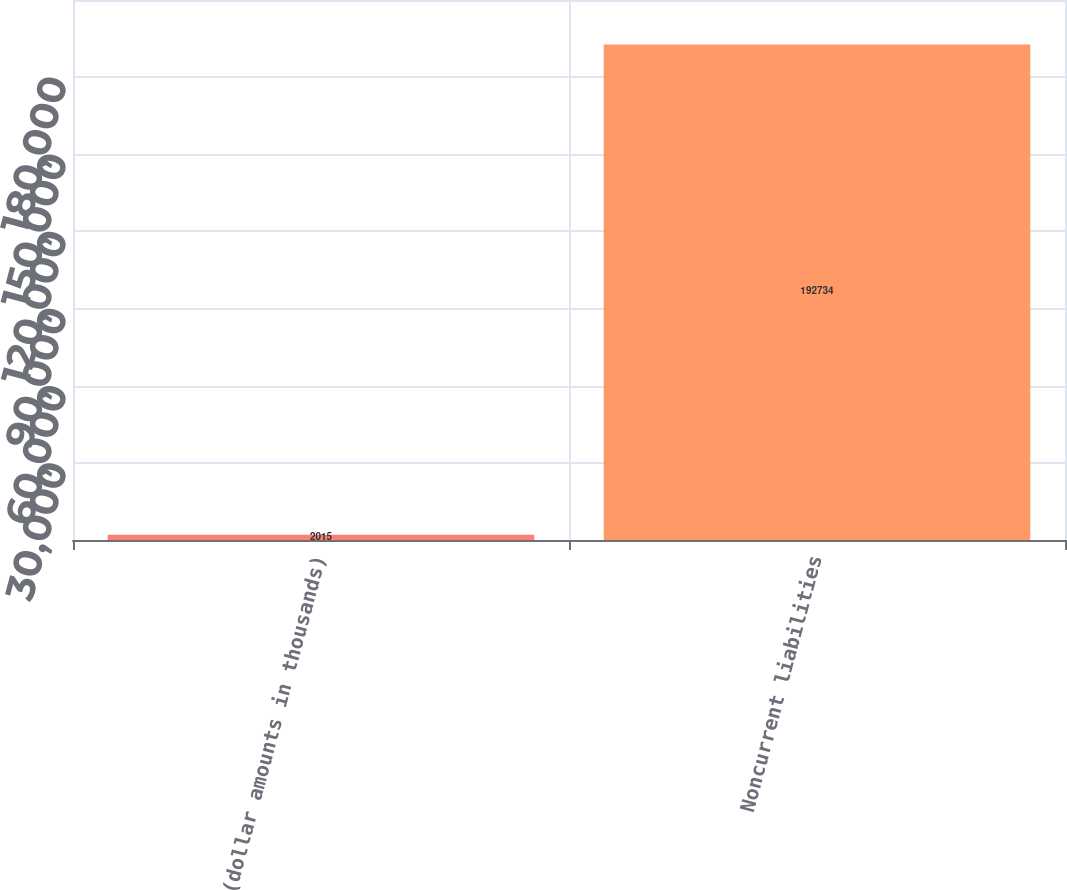Convert chart. <chart><loc_0><loc_0><loc_500><loc_500><bar_chart><fcel>(dollar amounts in thousands)<fcel>Noncurrent liabilities<nl><fcel>2015<fcel>192734<nl></chart> 